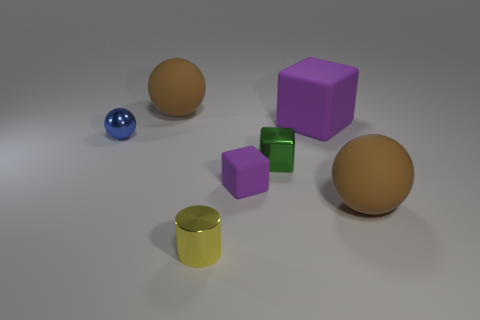Add 3 rubber objects. How many objects exist? 10 Subtract all blocks. How many objects are left? 4 Subtract 0 green cylinders. How many objects are left? 7 Subtract all purple things. Subtract all tiny rubber things. How many objects are left? 4 Add 2 small matte blocks. How many small matte blocks are left? 3 Add 5 small purple things. How many small purple things exist? 6 